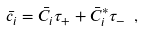<formula> <loc_0><loc_0><loc_500><loc_500>\bar { c } _ { i } = \bar { C } _ { i } \tau _ { + } + \bar { C } _ { i } ^ { * } \tau _ { - } \ ,</formula> 